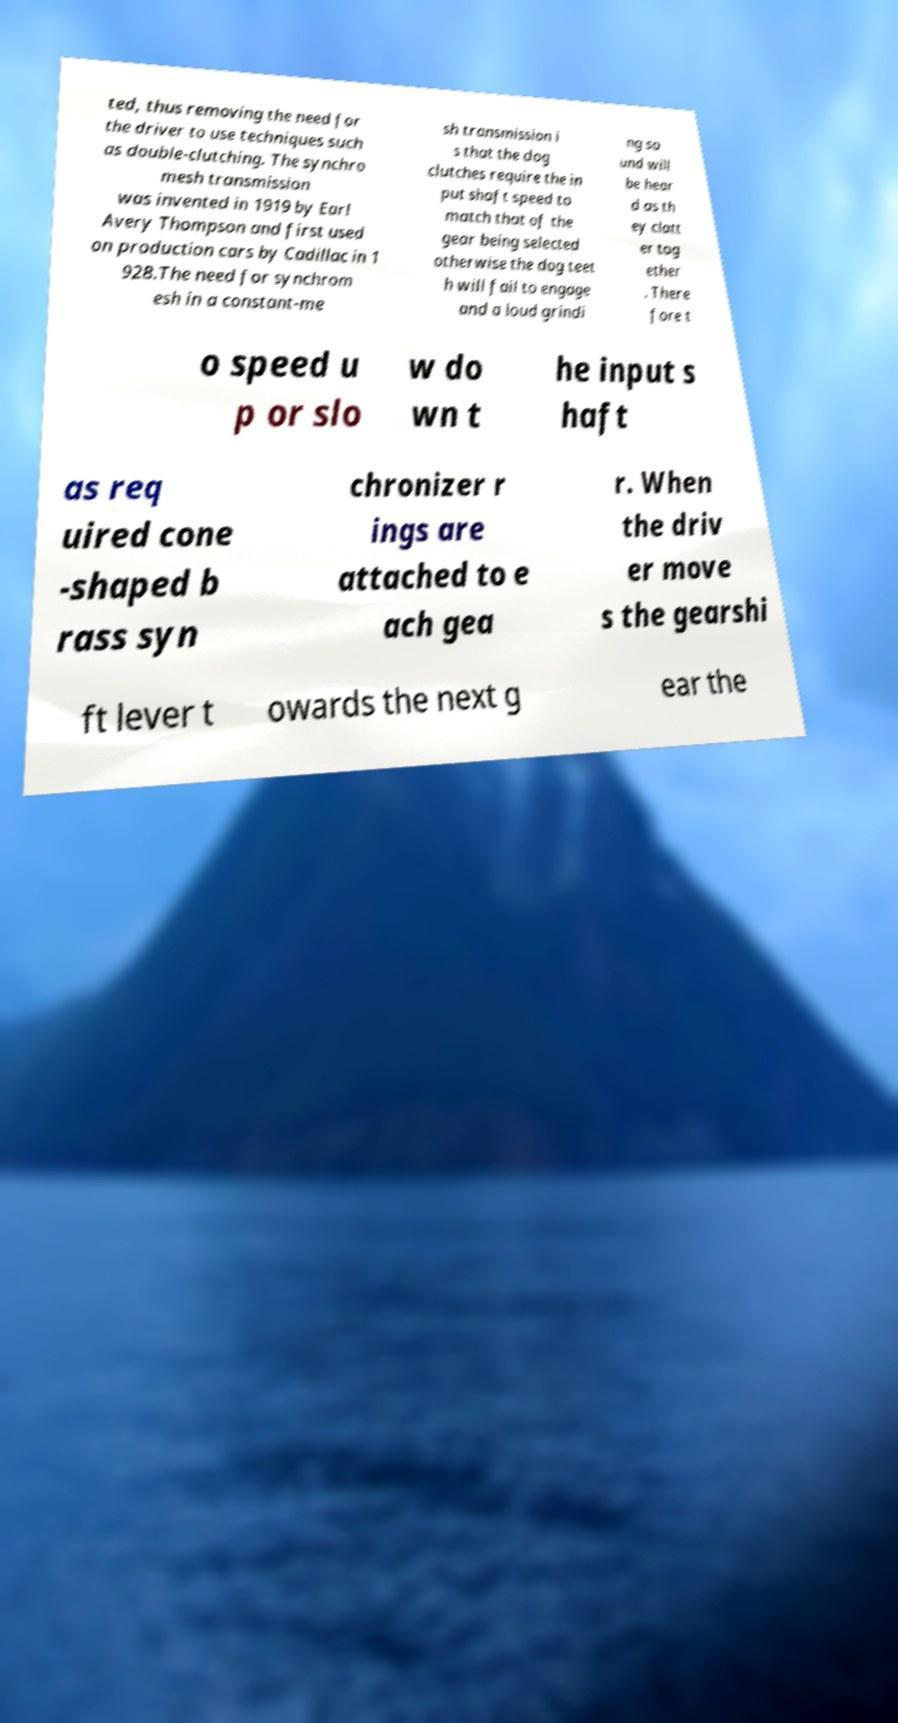Please read and relay the text visible in this image. What does it say? ted, thus removing the need for the driver to use techniques such as double-clutching. The synchro mesh transmission was invented in 1919 by Earl Avery Thompson and first used on production cars by Cadillac in 1 928.The need for synchrom esh in a constant-me sh transmission i s that the dog clutches require the in put shaft speed to match that of the gear being selected otherwise the dog teet h will fail to engage and a loud grindi ng so und will be hear d as th ey clatt er tog ether . There fore t o speed u p or slo w do wn t he input s haft as req uired cone -shaped b rass syn chronizer r ings are attached to e ach gea r. When the driv er move s the gearshi ft lever t owards the next g ear the 